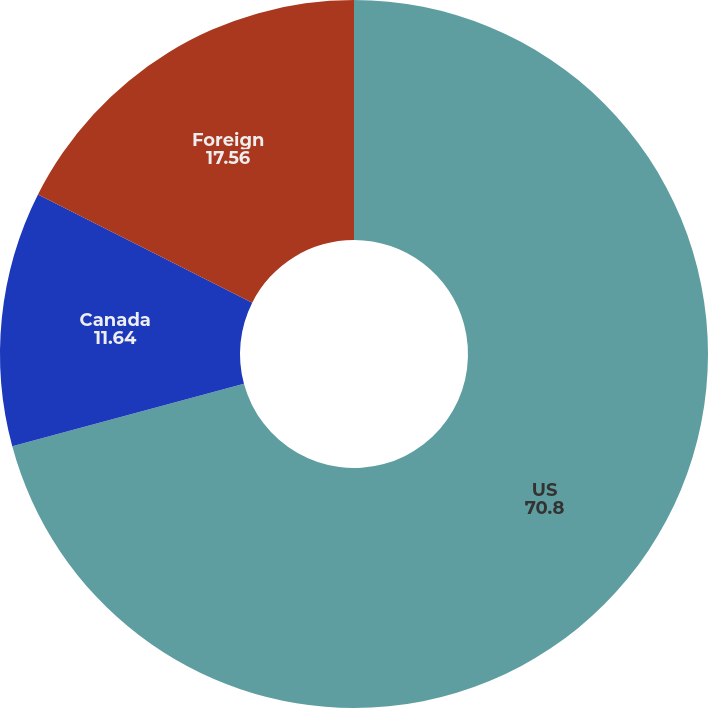Convert chart to OTSL. <chart><loc_0><loc_0><loc_500><loc_500><pie_chart><fcel>US<fcel>Canada<fcel>Foreign<nl><fcel>70.8%<fcel>11.64%<fcel>17.56%<nl></chart> 